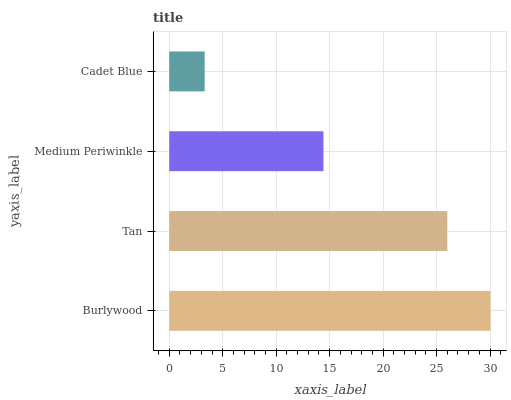Is Cadet Blue the minimum?
Answer yes or no. Yes. Is Burlywood the maximum?
Answer yes or no. Yes. Is Tan the minimum?
Answer yes or no. No. Is Tan the maximum?
Answer yes or no. No. Is Burlywood greater than Tan?
Answer yes or no. Yes. Is Tan less than Burlywood?
Answer yes or no. Yes. Is Tan greater than Burlywood?
Answer yes or no. No. Is Burlywood less than Tan?
Answer yes or no. No. Is Tan the high median?
Answer yes or no. Yes. Is Medium Periwinkle the low median?
Answer yes or no. Yes. Is Cadet Blue the high median?
Answer yes or no. No. Is Burlywood the low median?
Answer yes or no. No. 